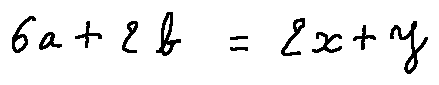Convert formula to latex. <formula><loc_0><loc_0><loc_500><loc_500>6 a + 2 b = 2 x + y</formula> 